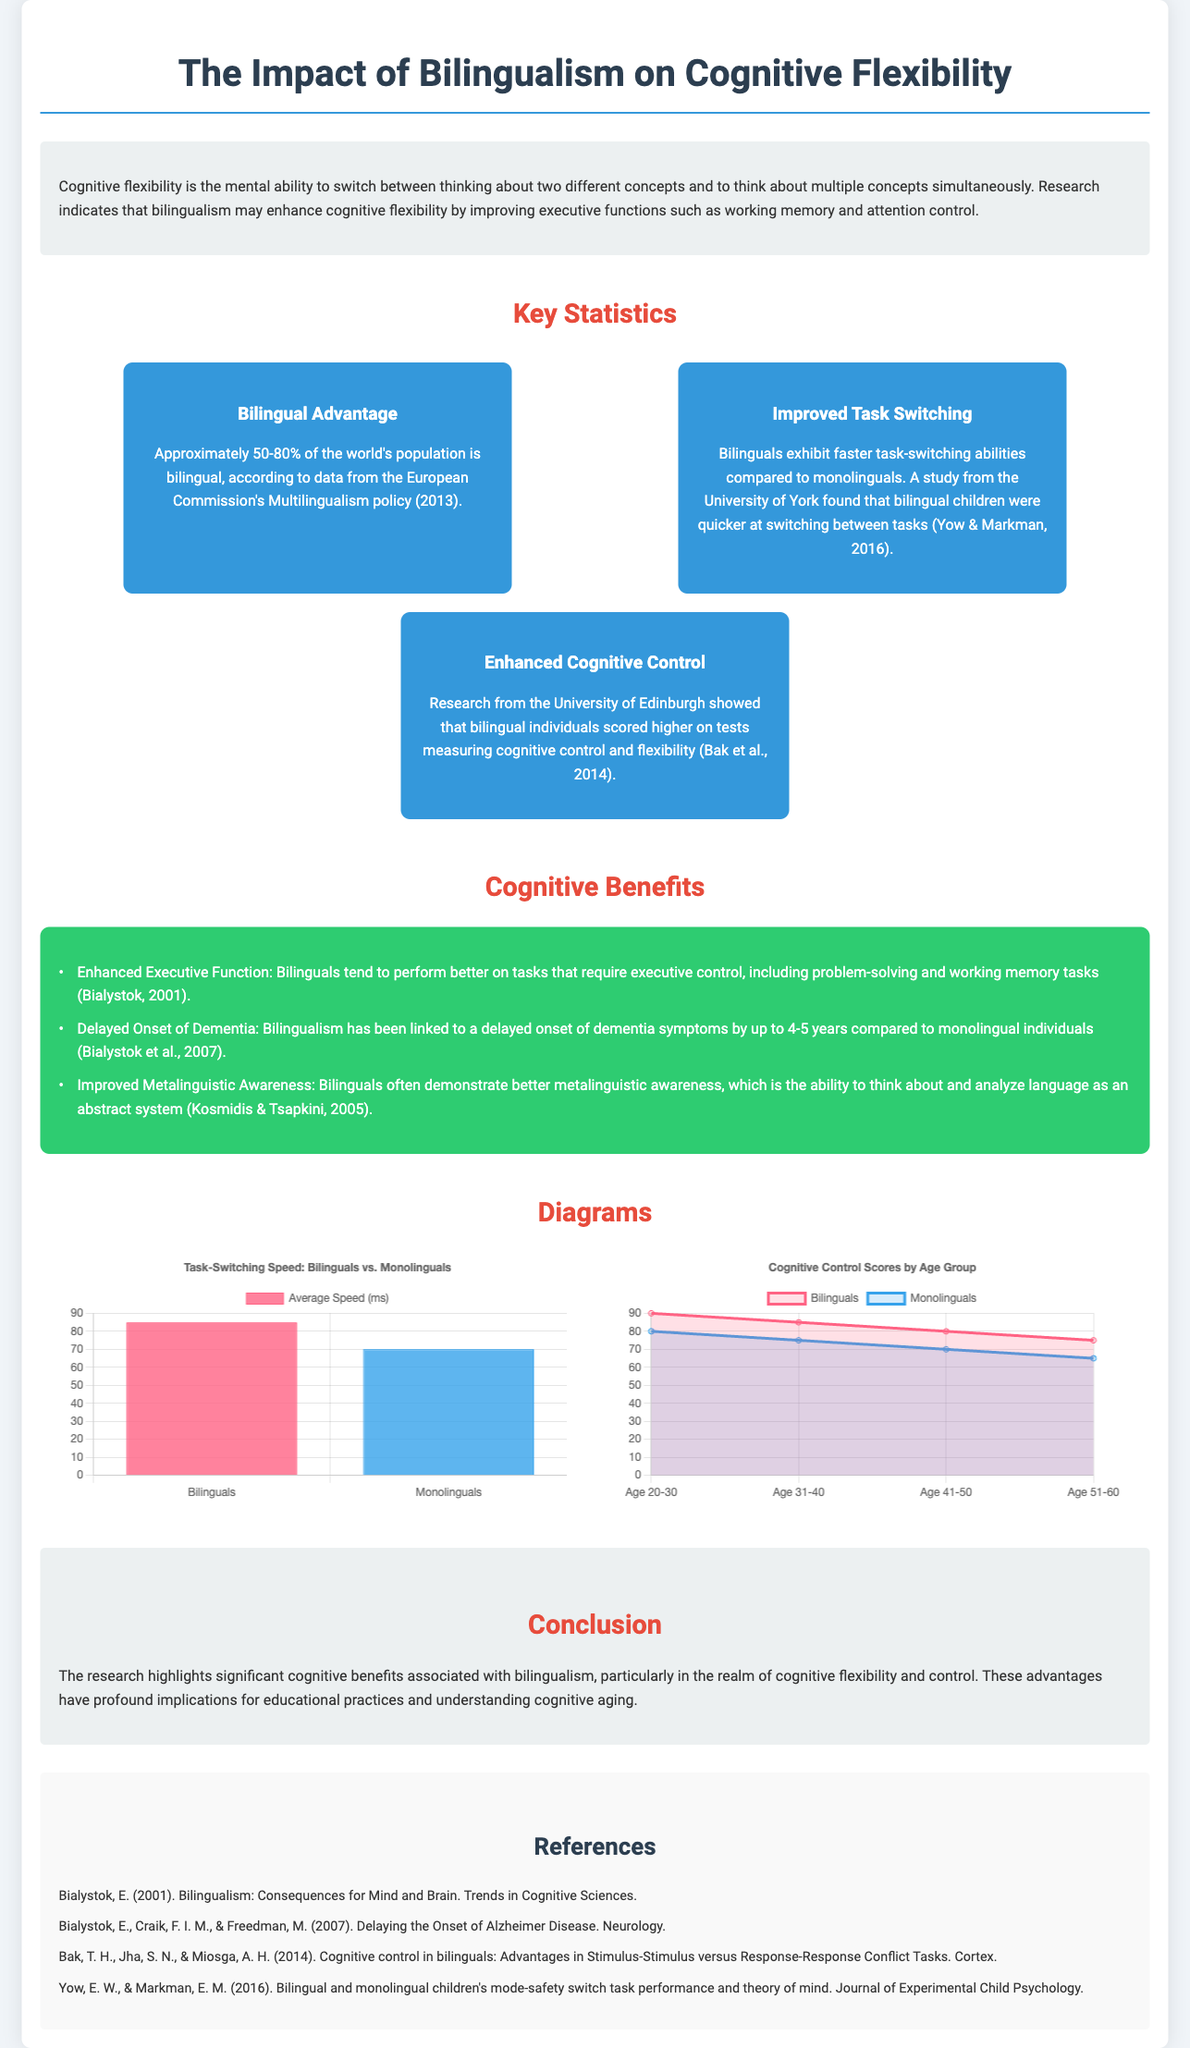What percentage of the world's population is bilingual? The document states that approximately 50-80% of the world's population is bilingual, according to data from the European Commission's Multilingualism policy.
Answer: 50-80% What is the average speed in milliseconds for bilinguals in task switching? The bar chart indicates that bilinguals have an average speed of 85 milliseconds in task-switching abilities.
Answer: 85 Which study established that bilingual children show faster task-switching? The document references a study from the University of York conducted by Yow and Markman in 2016 that found bilingual children were quicker at switching tasks.
Answer: University of York How much has bilingualism been linked to the delayed onset of dementia? The research indicates that bilingualism has been linked to a delayed onset of dementia symptoms by up to 4-5 years compared to monolingual individuals.
Answer: 4-5 years What cognitive benefit is associated with bilingualism as mentioned in the document? The document lists enhanced executive function as a cognitive benefit that bilinguals tend to perform better on tasks requiring executive control.
Answer: Enhanced Executive Function What does the line chart depict in terms of cognitive control scores? The line chart shows cognitive control scores for bilinguals and monolinguals across different age groups, indicating trends in their performance.
Answer: Cognitive control scores by age group Which age group shows a higher cognitive control score for bilinguals in the line chart? According to the line chart, bilinguals have a higher cognitive control score than monolinguals in every age group presented.
Answer: All age groups What does the title of the infographic suggest? The title of the infographic indicates that it will explore the impact of bilingualism specifically on cognitive flexibility.
Answer: The Impact of Bilingualism on Cognitive Flexibility 